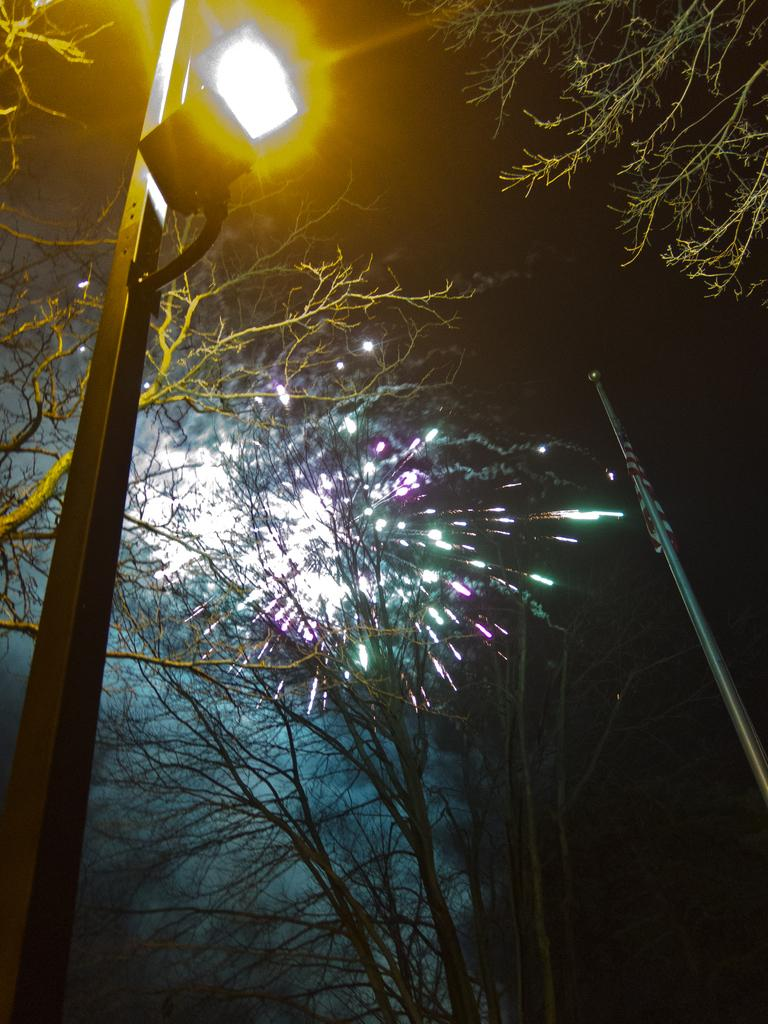What type of vegetation can be seen in the image? There are trees in the image. What artificial light source is present in the image? There is a street light in the image. Where is the flag located in the image? The flag is on a pole on the right side of the image. What is happening behind the trees in the image? Fireworks are visible behind the trees. What type of mist can be seen surrounding the trees in the image? There is no mist present in the image; only trees, a street light, a flag, and fireworks are visible. What type of snack is being served to the cats in the image? There are no cats or snacks present in the image. 